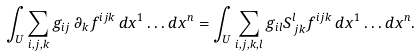Convert formula to latex. <formula><loc_0><loc_0><loc_500><loc_500>\int _ { U } \sum _ { i , j , k } g _ { i j } \, \partial _ { k } f ^ { i j k } \, d x ^ { 1 } \dots d x ^ { n } = \int _ { U } \sum _ { i , j , k , l } g _ { i l } S ^ { l } _ { \, j k } f ^ { i j k } \, d x ^ { 1 } \dots d x ^ { n } .</formula> 